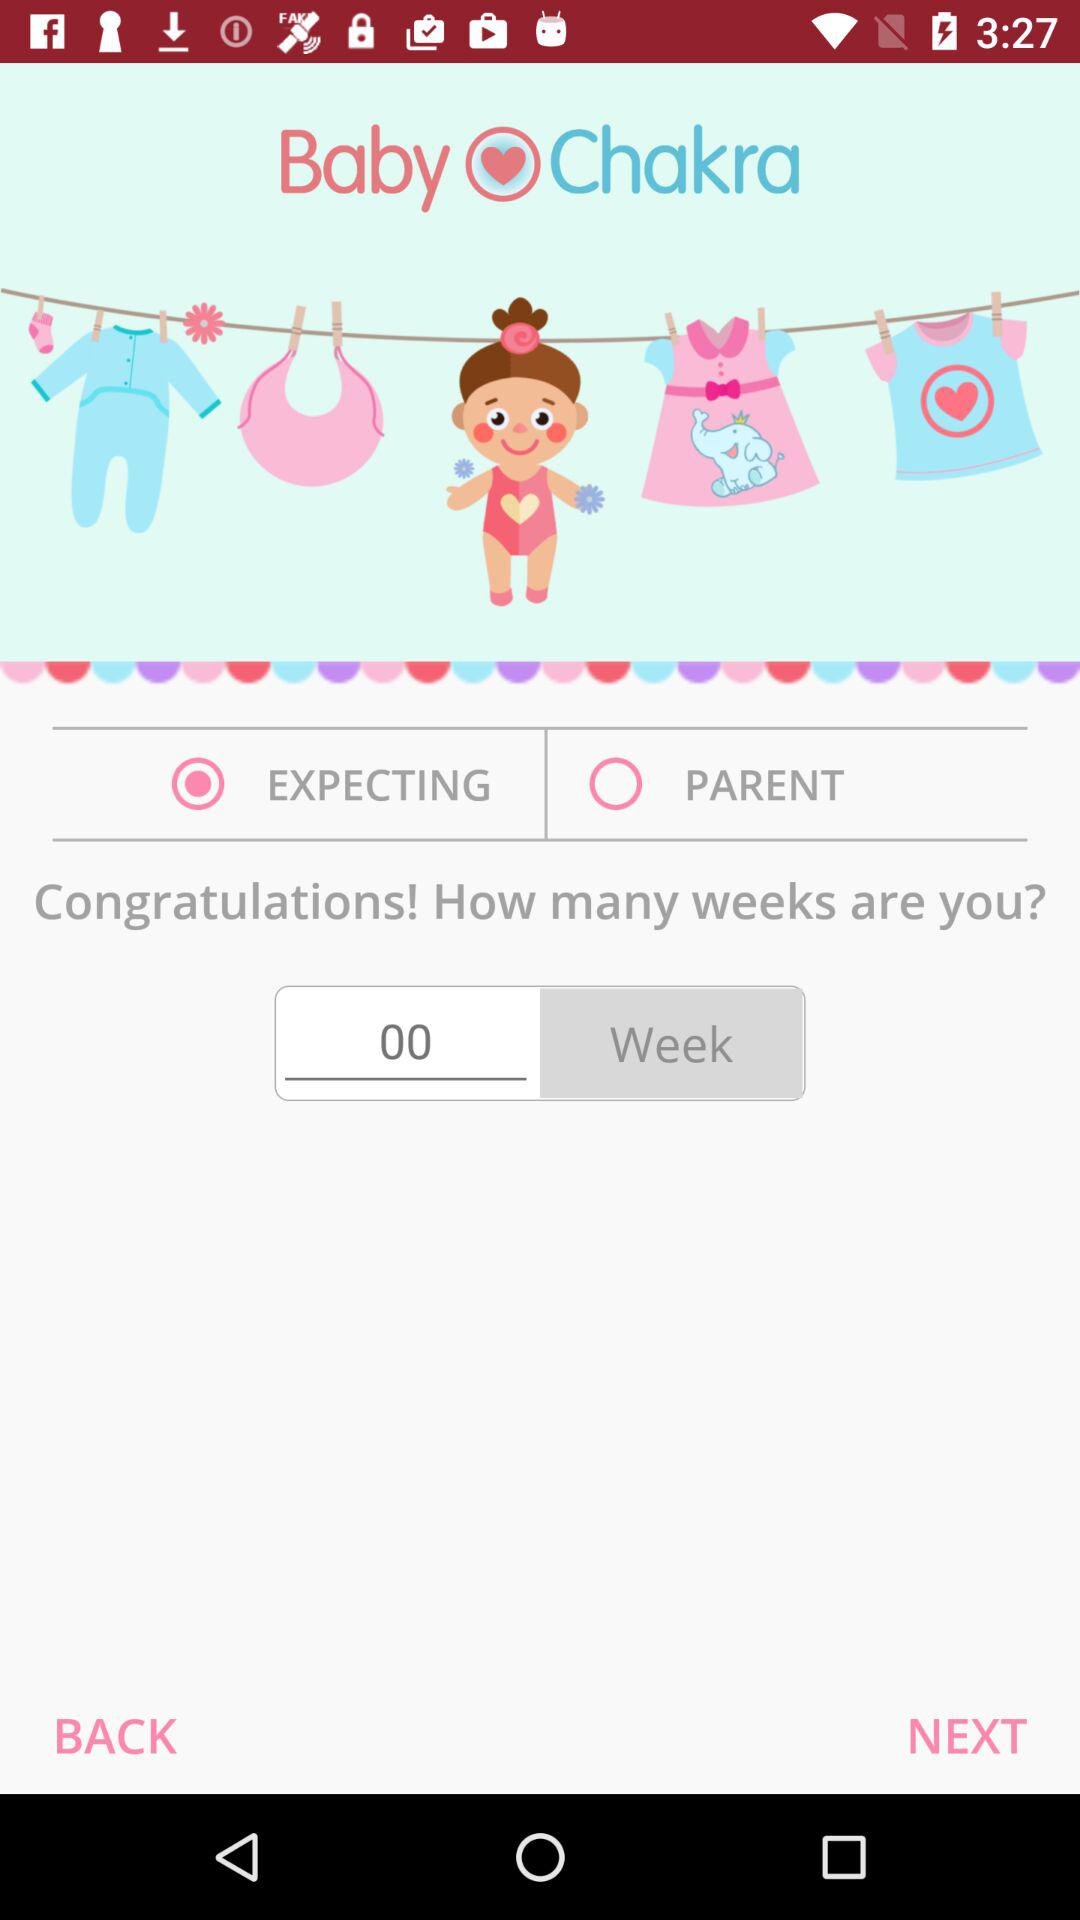What is the name of the application? The name of the application is "Baby Chakra". 